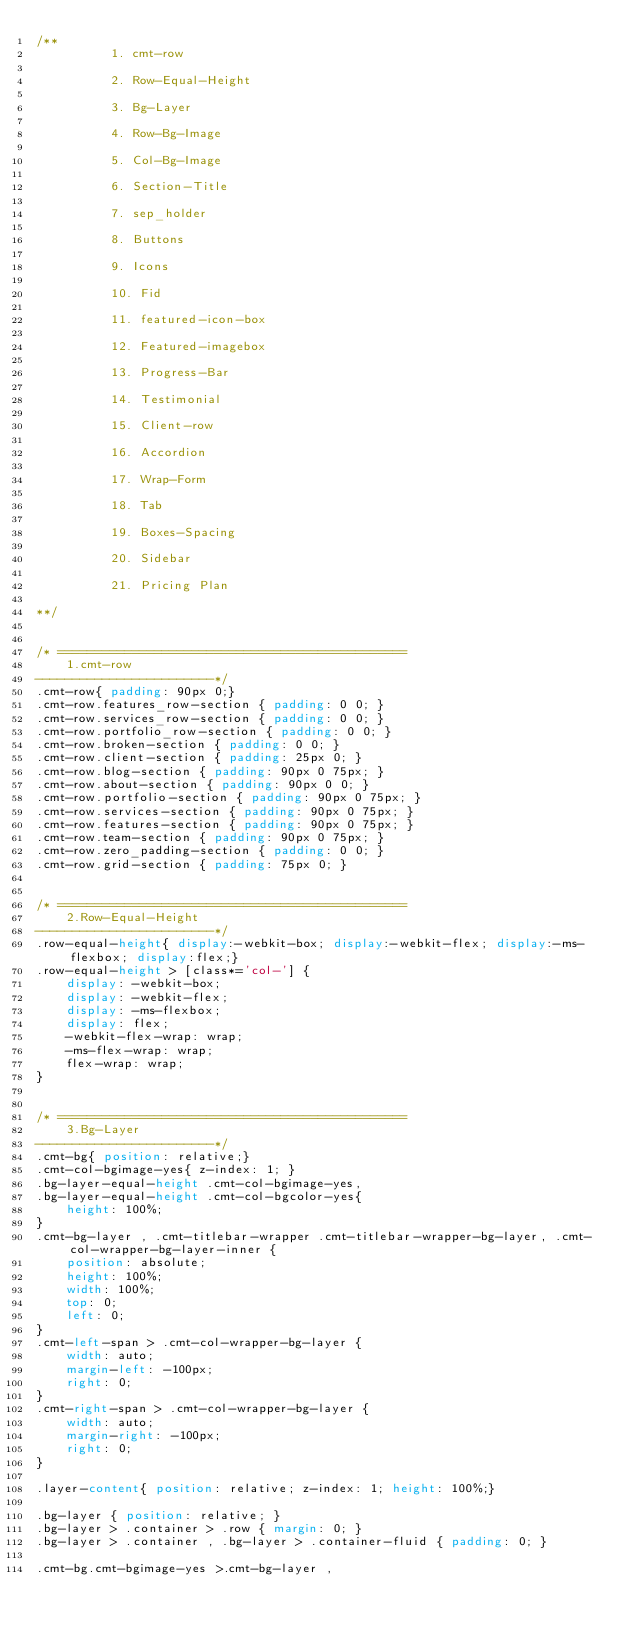<code> <loc_0><loc_0><loc_500><loc_500><_CSS_>/** 
          1. cmt-row 

          2. Row-Equal-Height

          3. Bg-Layer 

          4. Row-Bg-Image

          5. Col-Bg-Image

          6. Section-Title 

          7. sep_holder

          8. Buttons

          9. Icons

          10. Fid

          11. featured-icon-box

          12. Featured-imagebox

          13. Progress-Bar 

          14. Testimonial

          15. Client-row

          16. Accordion

          17. Wrap-Form

          18. Tab

          19. Boxes-Spacing

          20. Sidebar

          21. Pricing Plan

**/


/* ===============================================
    1.cmt-row
------------------------*/
.cmt-row{ padding: 90px 0;}
.cmt-row.features_row-section { padding: 0 0; }
.cmt-row.services_row-section { padding: 0 0; }
.cmt-row.portfolio_row-section { padding: 0 0; }
.cmt-row.broken-section { padding: 0 0; }
.cmt-row.client-section { padding: 25px 0; }
.cmt-row.blog-section { padding: 90px 0 75px; }
.cmt-row.about-section { padding: 90px 0 0; }
.cmt-row.portfolio-section { padding: 90px 0 75px; }
.cmt-row.services-section { padding: 90px 0 75px; }
.cmt-row.features-section { padding: 90px 0 75px; }
.cmt-row.team-section { padding: 90px 0 75px; }
.cmt-row.zero_padding-section { padding: 0 0; }
.cmt-row.grid-section { padding: 75px 0; }


/* ===============================================
    2.Row-Equal-Height
------------------------*/
.row-equal-height{ display:-webkit-box; display:-webkit-flex; display:-ms-flexbox; display:flex;}
.row-equal-height > [class*='col-'] { 
    display: -webkit-box; 
    display: -webkit-flex; 
    display: -ms-flexbox;
    display: flex;
    -webkit-flex-wrap: wrap;
    -ms-flex-wrap: wrap;
    flex-wrap: wrap;
}


/* ===============================================
    3.Bg-Layer 
------------------------*/
.cmt-bg{ position: relative;}
.cmt-col-bgimage-yes{ z-index: 1; }
.bg-layer-equal-height .cmt-col-bgimage-yes, 
.bg-layer-equal-height .cmt-col-bgcolor-yes{ 
    height: 100%;
}
.cmt-bg-layer , .cmt-titlebar-wrapper .cmt-titlebar-wrapper-bg-layer, .cmt-col-wrapper-bg-layer-inner {
    position: absolute;
    height: 100%;
    width: 100%; 
    top: 0;
    left: 0;
}
.cmt-left-span > .cmt-col-wrapper-bg-layer {
    width: auto;
    margin-left: -100px;
    right: 0;
}
.cmt-right-span > .cmt-col-wrapper-bg-layer {
    width: auto;
    margin-right: -100px;
    right: 0;
}

.layer-content{ position: relative; z-index: 1; height: 100%;}

.bg-layer { position: relative; }
.bg-layer > .container > .row { margin: 0; }
.bg-layer > .container , .bg-layer > .container-fluid { padding: 0; }

.cmt-bg.cmt-bgimage-yes >.cmt-bg-layer ,</code> 